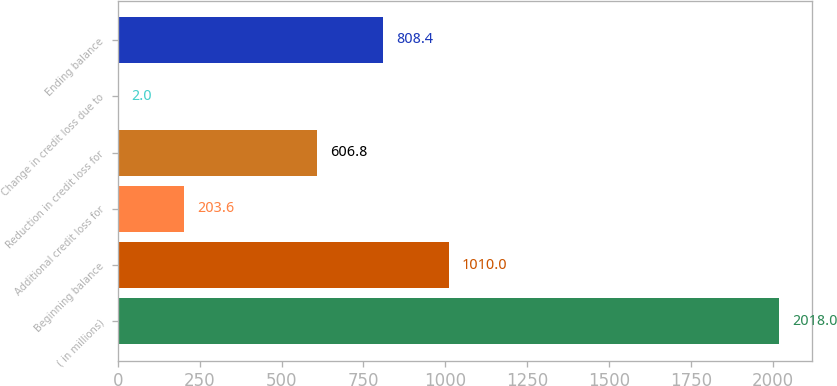<chart> <loc_0><loc_0><loc_500><loc_500><bar_chart><fcel>( in millions)<fcel>Beginning balance<fcel>Additional credit loss for<fcel>Reduction in credit loss for<fcel>Change in credit loss due to<fcel>Ending balance<nl><fcel>2018<fcel>1010<fcel>203.6<fcel>606.8<fcel>2<fcel>808.4<nl></chart> 